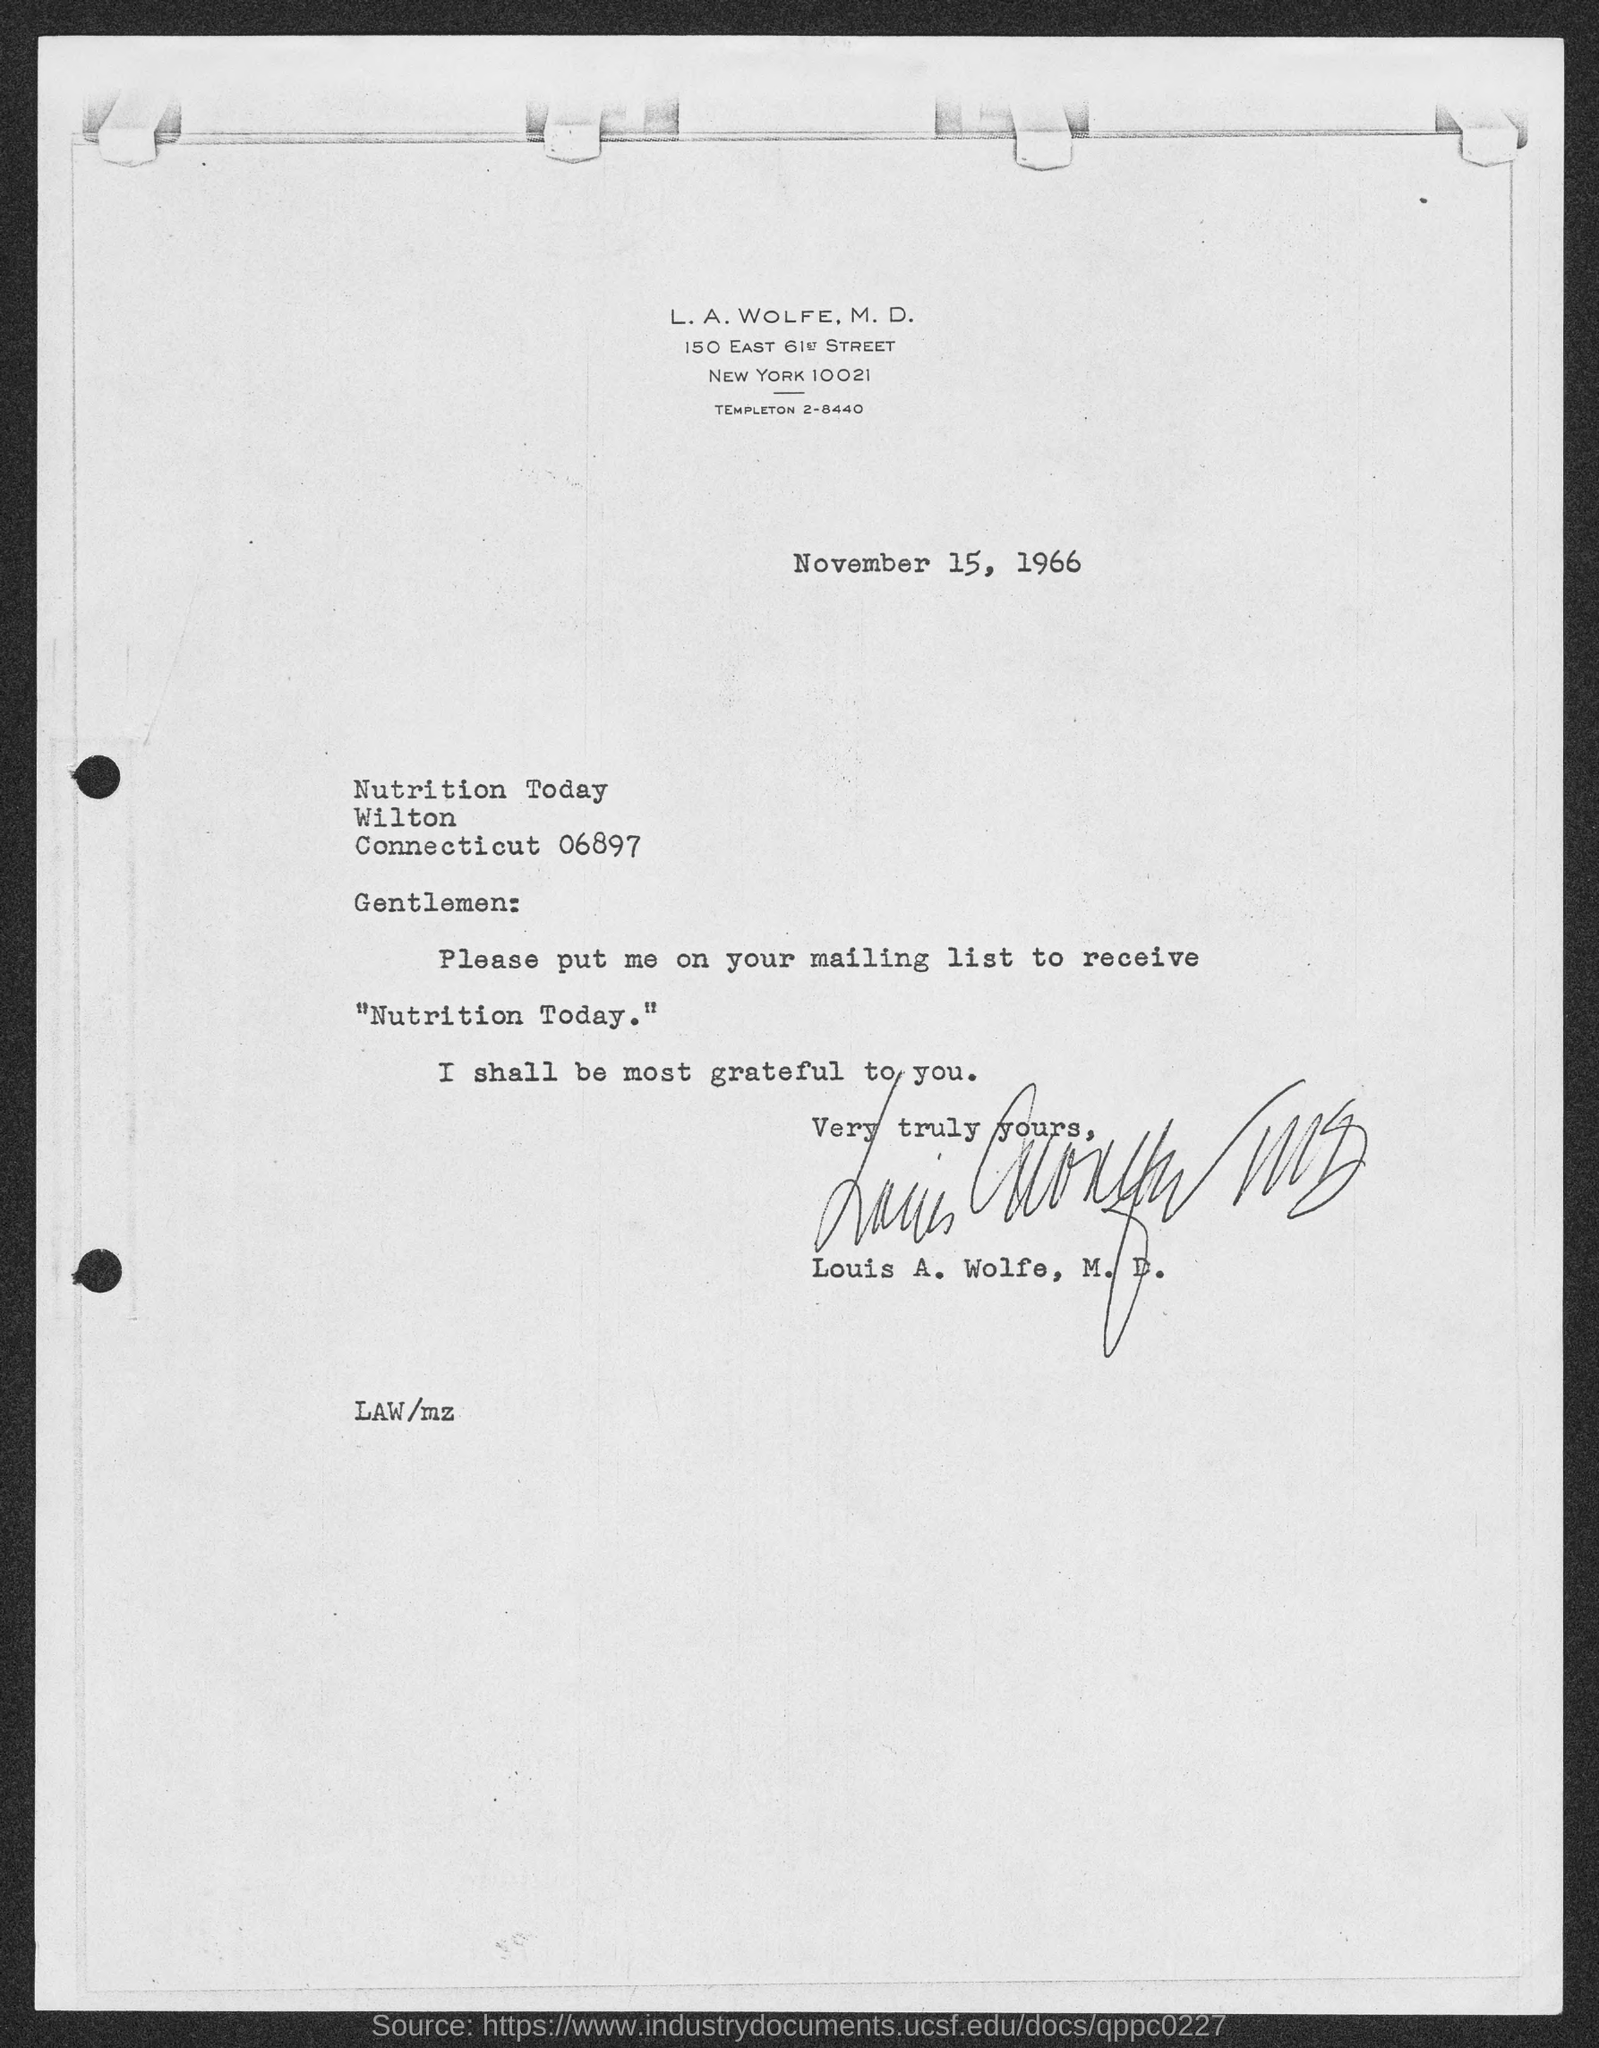Specify some key components in this picture. The date mentioned in this letter is November 15, 1966. 